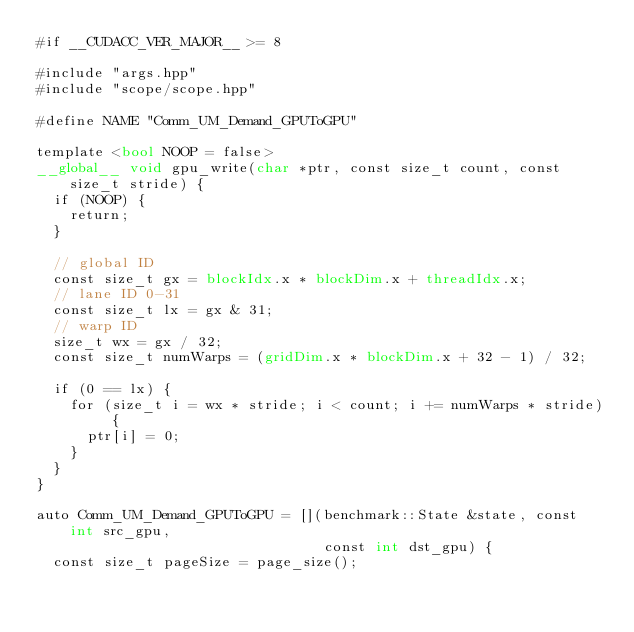<code> <loc_0><loc_0><loc_500><loc_500><_Cuda_>#if __CUDACC_VER_MAJOR__ >= 8

#include "args.hpp"
#include "scope/scope.hpp"

#define NAME "Comm_UM_Demand_GPUToGPU"

template <bool NOOP = false>
__global__ void gpu_write(char *ptr, const size_t count, const size_t stride) {
  if (NOOP) {
    return;
  }

  // global ID
  const size_t gx = blockIdx.x * blockDim.x + threadIdx.x;
  // lane ID 0-31
  const size_t lx = gx & 31;
  // warp ID
  size_t wx = gx / 32;
  const size_t numWarps = (gridDim.x * blockDim.x + 32 - 1) / 32;

  if (0 == lx) {
    for (size_t i = wx * stride; i < count; i += numWarps * stride) {
      ptr[i] = 0;
    }
  }
}

auto Comm_UM_Demand_GPUToGPU = [](benchmark::State &state, const int src_gpu,
                                  const int dst_gpu) {
  const size_t pageSize = page_size();
</code> 